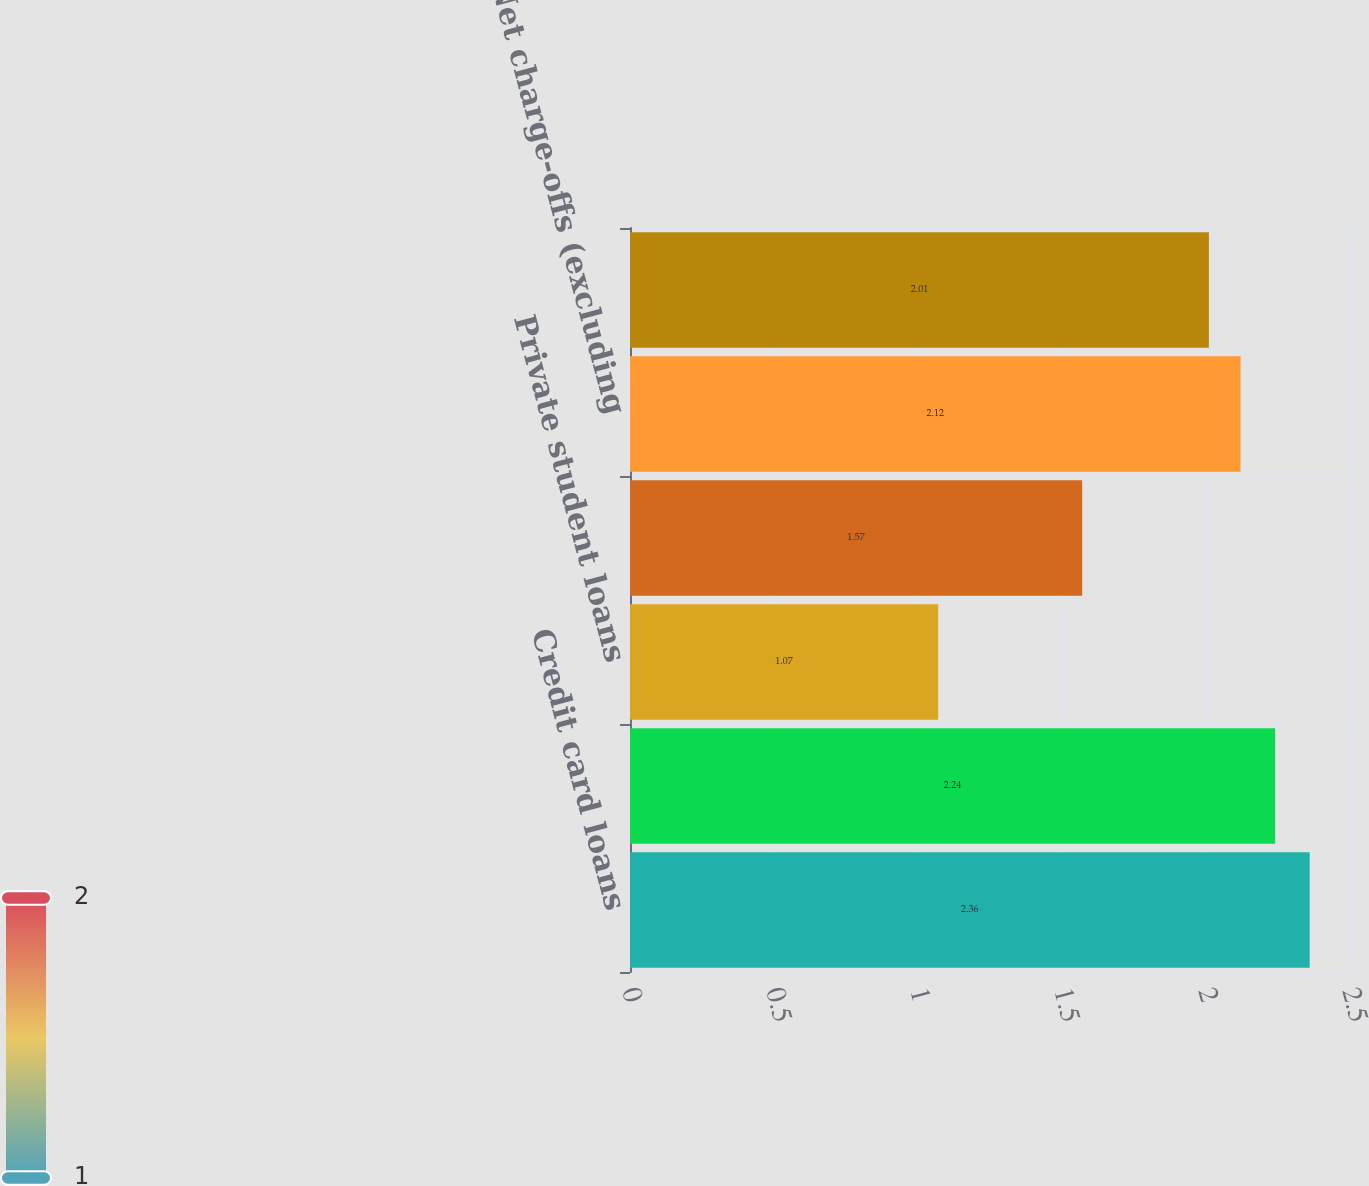<chart> <loc_0><loc_0><loc_500><loc_500><bar_chart><fcel>Credit card loans<fcel>Personal loans<fcel>Private student loans<fcel>Total other loans<fcel>Net charge-offs (excluding<fcel>Net charge-offs (including<nl><fcel>2.36<fcel>2.24<fcel>1.07<fcel>1.57<fcel>2.12<fcel>2.01<nl></chart> 